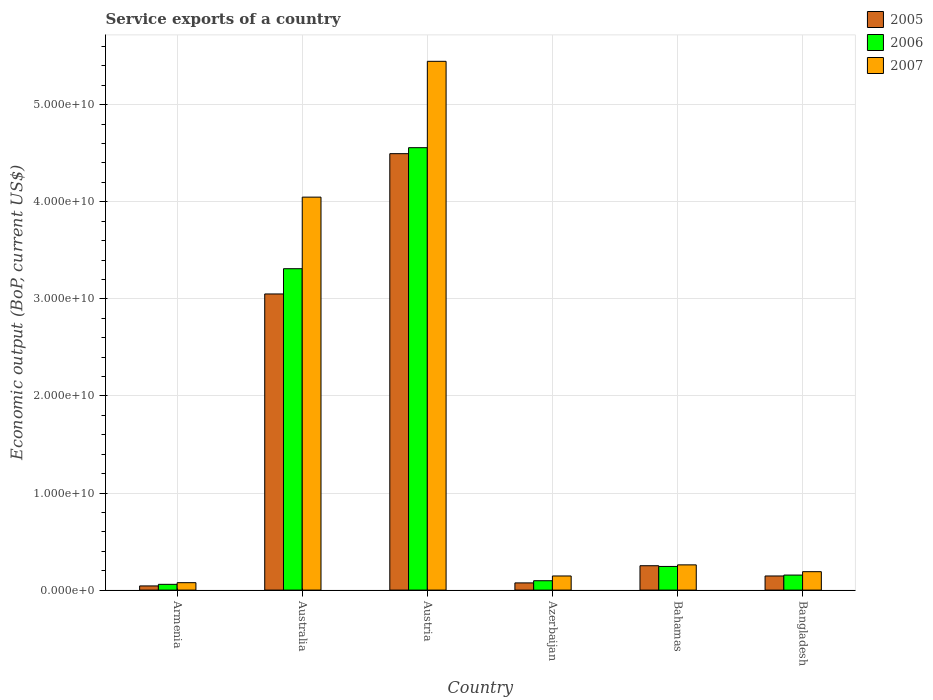How many different coloured bars are there?
Provide a short and direct response. 3. How many bars are there on the 5th tick from the left?
Offer a terse response. 3. What is the service exports in 2005 in Austria?
Your answer should be compact. 4.50e+1. Across all countries, what is the maximum service exports in 2005?
Your response must be concise. 4.50e+1. Across all countries, what is the minimum service exports in 2005?
Your answer should be compact. 4.30e+08. In which country was the service exports in 2007 maximum?
Offer a terse response. Austria. In which country was the service exports in 2006 minimum?
Your answer should be compact. Armenia. What is the total service exports in 2007 in the graph?
Ensure brevity in your answer.  1.02e+11. What is the difference between the service exports in 2007 in Armenia and that in Azerbaijan?
Your response must be concise. -6.91e+08. What is the difference between the service exports in 2007 in Bangladesh and the service exports in 2006 in Azerbaijan?
Your answer should be compact. 9.32e+08. What is the average service exports in 2005 per country?
Provide a succinct answer. 1.34e+1. What is the difference between the service exports of/in 2006 and service exports of/in 2007 in Bangladesh?
Provide a succinct answer. -3.48e+08. In how many countries, is the service exports in 2005 greater than 38000000000 US$?
Your answer should be very brief. 1. What is the ratio of the service exports in 2006 in Azerbaijan to that in Bahamas?
Provide a short and direct response. 0.4. Is the service exports in 2006 in Australia less than that in Bangladesh?
Your answer should be compact. No. What is the difference between the highest and the second highest service exports in 2006?
Provide a short and direct response. -3.07e+1. What is the difference between the highest and the lowest service exports in 2005?
Your answer should be compact. 4.45e+1. What does the 2nd bar from the left in Bangladesh represents?
Your answer should be compact. 2006. How many bars are there?
Ensure brevity in your answer.  18. Are all the bars in the graph horizontal?
Ensure brevity in your answer.  No. How many countries are there in the graph?
Offer a terse response. 6. What is the difference between two consecutive major ticks on the Y-axis?
Offer a terse response. 1.00e+1. Are the values on the major ticks of Y-axis written in scientific E-notation?
Keep it short and to the point. Yes. Does the graph contain grids?
Give a very brief answer. Yes. Where does the legend appear in the graph?
Offer a terse response. Top right. What is the title of the graph?
Ensure brevity in your answer.  Service exports of a country. Does "1988" appear as one of the legend labels in the graph?
Give a very brief answer. No. What is the label or title of the Y-axis?
Your answer should be compact. Economic output (BoP, current US$). What is the Economic output (BoP, current US$) in 2005 in Armenia?
Your answer should be compact. 4.30e+08. What is the Economic output (BoP, current US$) in 2006 in Armenia?
Offer a terse response. 5.94e+08. What is the Economic output (BoP, current US$) in 2007 in Armenia?
Provide a succinct answer. 7.64e+08. What is the Economic output (BoP, current US$) in 2005 in Australia?
Your response must be concise. 3.05e+1. What is the Economic output (BoP, current US$) of 2006 in Australia?
Keep it short and to the point. 3.31e+1. What is the Economic output (BoP, current US$) in 2007 in Australia?
Ensure brevity in your answer.  4.05e+1. What is the Economic output (BoP, current US$) of 2005 in Austria?
Your answer should be very brief. 4.50e+1. What is the Economic output (BoP, current US$) of 2006 in Austria?
Offer a very short reply. 4.56e+1. What is the Economic output (BoP, current US$) of 2007 in Austria?
Provide a short and direct response. 5.45e+1. What is the Economic output (BoP, current US$) in 2005 in Azerbaijan?
Give a very brief answer. 7.41e+08. What is the Economic output (BoP, current US$) of 2006 in Azerbaijan?
Provide a succinct answer. 9.65e+08. What is the Economic output (BoP, current US$) of 2007 in Azerbaijan?
Provide a short and direct response. 1.46e+09. What is the Economic output (BoP, current US$) of 2005 in Bahamas?
Ensure brevity in your answer.  2.51e+09. What is the Economic output (BoP, current US$) of 2006 in Bahamas?
Offer a terse response. 2.44e+09. What is the Economic output (BoP, current US$) in 2007 in Bahamas?
Your response must be concise. 2.60e+09. What is the Economic output (BoP, current US$) of 2005 in Bangladesh?
Your response must be concise. 1.45e+09. What is the Economic output (BoP, current US$) of 2006 in Bangladesh?
Your response must be concise. 1.55e+09. What is the Economic output (BoP, current US$) of 2007 in Bangladesh?
Provide a succinct answer. 1.90e+09. Across all countries, what is the maximum Economic output (BoP, current US$) of 2005?
Ensure brevity in your answer.  4.50e+1. Across all countries, what is the maximum Economic output (BoP, current US$) of 2006?
Make the answer very short. 4.56e+1. Across all countries, what is the maximum Economic output (BoP, current US$) in 2007?
Provide a succinct answer. 5.45e+1. Across all countries, what is the minimum Economic output (BoP, current US$) of 2005?
Make the answer very short. 4.30e+08. Across all countries, what is the minimum Economic output (BoP, current US$) in 2006?
Keep it short and to the point. 5.94e+08. Across all countries, what is the minimum Economic output (BoP, current US$) of 2007?
Provide a succinct answer. 7.64e+08. What is the total Economic output (BoP, current US$) of 2005 in the graph?
Offer a very short reply. 8.06e+1. What is the total Economic output (BoP, current US$) in 2006 in the graph?
Provide a short and direct response. 8.42e+1. What is the total Economic output (BoP, current US$) in 2007 in the graph?
Offer a very short reply. 1.02e+11. What is the difference between the Economic output (BoP, current US$) of 2005 in Armenia and that in Australia?
Your answer should be very brief. -3.01e+1. What is the difference between the Economic output (BoP, current US$) in 2006 in Armenia and that in Australia?
Offer a terse response. -3.25e+1. What is the difference between the Economic output (BoP, current US$) of 2007 in Armenia and that in Australia?
Your answer should be compact. -3.97e+1. What is the difference between the Economic output (BoP, current US$) in 2005 in Armenia and that in Austria?
Give a very brief answer. -4.45e+1. What is the difference between the Economic output (BoP, current US$) of 2006 in Armenia and that in Austria?
Provide a short and direct response. -4.50e+1. What is the difference between the Economic output (BoP, current US$) of 2007 in Armenia and that in Austria?
Your answer should be compact. -5.37e+1. What is the difference between the Economic output (BoP, current US$) in 2005 in Armenia and that in Azerbaijan?
Provide a short and direct response. -3.11e+08. What is the difference between the Economic output (BoP, current US$) of 2006 in Armenia and that in Azerbaijan?
Provide a succinct answer. -3.72e+08. What is the difference between the Economic output (BoP, current US$) of 2007 in Armenia and that in Azerbaijan?
Your answer should be very brief. -6.91e+08. What is the difference between the Economic output (BoP, current US$) of 2005 in Armenia and that in Bahamas?
Give a very brief answer. -2.08e+09. What is the difference between the Economic output (BoP, current US$) of 2006 in Armenia and that in Bahamas?
Offer a terse response. -1.84e+09. What is the difference between the Economic output (BoP, current US$) of 2007 in Armenia and that in Bahamas?
Offer a terse response. -1.84e+09. What is the difference between the Economic output (BoP, current US$) in 2005 in Armenia and that in Bangladesh?
Give a very brief answer. -1.02e+09. What is the difference between the Economic output (BoP, current US$) in 2006 in Armenia and that in Bangladesh?
Make the answer very short. -9.55e+08. What is the difference between the Economic output (BoP, current US$) in 2007 in Armenia and that in Bangladesh?
Keep it short and to the point. -1.13e+09. What is the difference between the Economic output (BoP, current US$) of 2005 in Australia and that in Austria?
Provide a short and direct response. -1.45e+1. What is the difference between the Economic output (BoP, current US$) of 2006 in Australia and that in Austria?
Offer a terse response. -1.25e+1. What is the difference between the Economic output (BoP, current US$) in 2007 in Australia and that in Austria?
Your answer should be compact. -1.40e+1. What is the difference between the Economic output (BoP, current US$) of 2005 in Australia and that in Azerbaijan?
Give a very brief answer. 2.98e+1. What is the difference between the Economic output (BoP, current US$) in 2006 in Australia and that in Azerbaijan?
Your response must be concise. 3.21e+1. What is the difference between the Economic output (BoP, current US$) in 2007 in Australia and that in Azerbaijan?
Provide a succinct answer. 3.90e+1. What is the difference between the Economic output (BoP, current US$) in 2005 in Australia and that in Bahamas?
Your answer should be very brief. 2.80e+1. What is the difference between the Economic output (BoP, current US$) in 2006 in Australia and that in Bahamas?
Provide a short and direct response. 3.07e+1. What is the difference between the Economic output (BoP, current US$) of 2007 in Australia and that in Bahamas?
Your response must be concise. 3.79e+1. What is the difference between the Economic output (BoP, current US$) in 2005 in Australia and that in Bangladesh?
Give a very brief answer. 2.91e+1. What is the difference between the Economic output (BoP, current US$) in 2006 in Australia and that in Bangladesh?
Offer a very short reply. 3.16e+1. What is the difference between the Economic output (BoP, current US$) in 2007 in Australia and that in Bangladesh?
Ensure brevity in your answer.  3.86e+1. What is the difference between the Economic output (BoP, current US$) of 2005 in Austria and that in Azerbaijan?
Offer a very short reply. 4.42e+1. What is the difference between the Economic output (BoP, current US$) in 2006 in Austria and that in Azerbaijan?
Keep it short and to the point. 4.46e+1. What is the difference between the Economic output (BoP, current US$) of 2007 in Austria and that in Azerbaijan?
Make the answer very short. 5.30e+1. What is the difference between the Economic output (BoP, current US$) in 2005 in Austria and that in Bahamas?
Make the answer very short. 4.24e+1. What is the difference between the Economic output (BoP, current US$) in 2006 in Austria and that in Bahamas?
Your answer should be very brief. 4.31e+1. What is the difference between the Economic output (BoP, current US$) of 2007 in Austria and that in Bahamas?
Keep it short and to the point. 5.19e+1. What is the difference between the Economic output (BoP, current US$) in 2005 in Austria and that in Bangladesh?
Offer a terse response. 4.35e+1. What is the difference between the Economic output (BoP, current US$) in 2006 in Austria and that in Bangladesh?
Provide a succinct answer. 4.40e+1. What is the difference between the Economic output (BoP, current US$) in 2007 in Austria and that in Bangladesh?
Keep it short and to the point. 5.26e+1. What is the difference between the Economic output (BoP, current US$) in 2005 in Azerbaijan and that in Bahamas?
Your answer should be very brief. -1.77e+09. What is the difference between the Economic output (BoP, current US$) of 2006 in Azerbaijan and that in Bahamas?
Provide a short and direct response. -1.47e+09. What is the difference between the Economic output (BoP, current US$) of 2007 in Azerbaijan and that in Bahamas?
Provide a succinct answer. -1.14e+09. What is the difference between the Economic output (BoP, current US$) in 2005 in Azerbaijan and that in Bangladesh?
Provide a short and direct response. -7.13e+08. What is the difference between the Economic output (BoP, current US$) in 2006 in Azerbaijan and that in Bangladesh?
Give a very brief answer. -5.84e+08. What is the difference between the Economic output (BoP, current US$) of 2007 in Azerbaijan and that in Bangladesh?
Ensure brevity in your answer.  -4.42e+08. What is the difference between the Economic output (BoP, current US$) in 2005 in Bahamas and that in Bangladesh?
Your answer should be compact. 1.06e+09. What is the difference between the Economic output (BoP, current US$) of 2006 in Bahamas and that in Bangladesh?
Offer a terse response. 8.87e+08. What is the difference between the Economic output (BoP, current US$) in 2007 in Bahamas and that in Bangladesh?
Give a very brief answer. 7.02e+08. What is the difference between the Economic output (BoP, current US$) of 2005 in Armenia and the Economic output (BoP, current US$) of 2006 in Australia?
Keep it short and to the point. -3.27e+1. What is the difference between the Economic output (BoP, current US$) of 2005 in Armenia and the Economic output (BoP, current US$) of 2007 in Australia?
Offer a terse response. -4.01e+1. What is the difference between the Economic output (BoP, current US$) of 2006 in Armenia and the Economic output (BoP, current US$) of 2007 in Australia?
Ensure brevity in your answer.  -3.99e+1. What is the difference between the Economic output (BoP, current US$) of 2005 in Armenia and the Economic output (BoP, current US$) of 2006 in Austria?
Provide a short and direct response. -4.51e+1. What is the difference between the Economic output (BoP, current US$) in 2005 in Armenia and the Economic output (BoP, current US$) in 2007 in Austria?
Provide a succinct answer. -5.40e+1. What is the difference between the Economic output (BoP, current US$) in 2006 in Armenia and the Economic output (BoP, current US$) in 2007 in Austria?
Ensure brevity in your answer.  -5.39e+1. What is the difference between the Economic output (BoP, current US$) in 2005 in Armenia and the Economic output (BoP, current US$) in 2006 in Azerbaijan?
Ensure brevity in your answer.  -5.35e+08. What is the difference between the Economic output (BoP, current US$) in 2005 in Armenia and the Economic output (BoP, current US$) in 2007 in Azerbaijan?
Your answer should be compact. -1.03e+09. What is the difference between the Economic output (BoP, current US$) of 2006 in Armenia and the Economic output (BoP, current US$) of 2007 in Azerbaijan?
Keep it short and to the point. -8.62e+08. What is the difference between the Economic output (BoP, current US$) of 2005 in Armenia and the Economic output (BoP, current US$) of 2006 in Bahamas?
Keep it short and to the point. -2.01e+09. What is the difference between the Economic output (BoP, current US$) in 2005 in Armenia and the Economic output (BoP, current US$) in 2007 in Bahamas?
Give a very brief answer. -2.17e+09. What is the difference between the Economic output (BoP, current US$) in 2006 in Armenia and the Economic output (BoP, current US$) in 2007 in Bahamas?
Offer a terse response. -2.01e+09. What is the difference between the Economic output (BoP, current US$) in 2005 in Armenia and the Economic output (BoP, current US$) in 2006 in Bangladesh?
Provide a short and direct response. -1.12e+09. What is the difference between the Economic output (BoP, current US$) of 2005 in Armenia and the Economic output (BoP, current US$) of 2007 in Bangladesh?
Keep it short and to the point. -1.47e+09. What is the difference between the Economic output (BoP, current US$) of 2006 in Armenia and the Economic output (BoP, current US$) of 2007 in Bangladesh?
Keep it short and to the point. -1.30e+09. What is the difference between the Economic output (BoP, current US$) of 2005 in Australia and the Economic output (BoP, current US$) of 2006 in Austria?
Your answer should be compact. -1.51e+1. What is the difference between the Economic output (BoP, current US$) of 2005 in Australia and the Economic output (BoP, current US$) of 2007 in Austria?
Ensure brevity in your answer.  -2.40e+1. What is the difference between the Economic output (BoP, current US$) of 2006 in Australia and the Economic output (BoP, current US$) of 2007 in Austria?
Offer a terse response. -2.14e+1. What is the difference between the Economic output (BoP, current US$) in 2005 in Australia and the Economic output (BoP, current US$) in 2006 in Azerbaijan?
Your response must be concise. 2.95e+1. What is the difference between the Economic output (BoP, current US$) of 2005 in Australia and the Economic output (BoP, current US$) of 2007 in Azerbaijan?
Offer a very short reply. 2.91e+1. What is the difference between the Economic output (BoP, current US$) in 2006 in Australia and the Economic output (BoP, current US$) in 2007 in Azerbaijan?
Provide a short and direct response. 3.17e+1. What is the difference between the Economic output (BoP, current US$) in 2005 in Australia and the Economic output (BoP, current US$) in 2006 in Bahamas?
Provide a short and direct response. 2.81e+1. What is the difference between the Economic output (BoP, current US$) of 2005 in Australia and the Economic output (BoP, current US$) of 2007 in Bahamas?
Ensure brevity in your answer.  2.79e+1. What is the difference between the Economic output (BoP, current US$) in 2006 in Australia and the Economic output (BoP, current US$) in 2007 in Bahamas?
Make the answer very short. 3.05e+1. What is the difference between the Economic output (BoP, current US$) of 2005 in Australia and the Economic output (BoP, current US$) of 2006 in Bangladesh?
Keep it short and to the point. 2.90e+1. What is the difference between the Economic output (BoP, current US$) of 2005 in Australia and the Economic output (BoP, current US$) of 2007 in Bangladesh?
Offer a very short reply. 2.86e+1. What is the difference between the Economic output (BoP, current US$) in 2006 in Australia and the Economic output (BoP, current US$) in 2007 in Bangladesh?
Provide a succinct answer. 3.12e+1. What is the difference between the Economic output (BoP, current US$) of 2005 in Austria and the Economic output (BoP, current US$) of 2006 in Azerbaijan?
Give a very brief answer. 4.40e+1. What is the difference between the Economic output (BoP, current US$) in 2005 in Austria and the Economic output (BoP, current US$) in 2007 in Azerbaijan?
Offer a very short reply. 4.35e+1. What is the difference between the Economic output (BoP, current US$) in 2006 in Austria and the Economic output (BoP, current US$) in 2007 in Azerbaijan?
Give a very brief answer. 4.41e+1. What is the difference between the Economic output (BoP, current US$) of 2005 in Austria and the Economic output (BoP, current US$) of 2006 in Bahamas?
Your answer should be compact. 4.25e+1. What is the difference between the Economic output (BoP, current US$) in 2005 in Austria and the Economic output (BoP, current US$) in 2007 in Bahamas?
Offer a very short reply. 4.24e+1. What is the difference between the Economic output (BoP, current US$) in 2006 in Austria and the Economic output (BoP, current US$) in 2007 in Bahamas?
Offer a terse response. 4.30e+1. What is the difference between the Economic output (BoP, current US$) of 2005 in Austria and the Economic output (BoP, current US$) of 2006 in Bangladesh?
Offer a very short reply. 4.34e+1. What is the difference between the Economic output (BoP, current US$) in 2005 in Austria and the Economic output (BoP, current US$) in 2007 in Bangladesh?
Your answer should be compact. 4.31e+1. What is the difference between the Economic output (BoP, current US$) in 2006 in Austria and the Economic output (BoP, current US$) in 2007 in Bangladesh?
Provide a succinct answer. 4.37e+1. What is the difference between the Economic output (BoP, current US$) in 2005 in Azerbaijan and the Economic output (BoP, current US$) in 2006 in Bahamas?
Ensure brevity in your answer.  -1.69e+09. What is the difference between the Economic output (BoP, current US$) of 2005 in Azerbaijan and the Economic output (BoP, current US$) of 2007 in Bahamas?
Make the answer very short. -1.86e+09. What is the difference between the Economic output (BoP, current US$) of 2006 in Azerbaijan and the Economic output (BoP, current US$) of 2007 in Bahamas?
Offer a very short reply. -1.63e+09. What is the difference between the Economic output (BoP, current US$) of 2005 in Azerbaijan and the Economic output (BoP, current US$) of 2006 in Bangladesh?
Keep it short and to the point. -8.08e+08. What is the difference between the Economic output (BoP, current US$) in 2005 in Azerbaijan and the Economic output (BoP, current US$) in 2007 in Bangladesh?
Ensure brevity in your answer.  -1.16e+09. What is the difference between the Economic output (BoP, current US$) of 2006 in Azerbaijan and the Economic output (BoP, current US$) of 2007 in Bangladesh?
Provide a short and direct response. -9.32e+08. What is the difference between the Economic output (BoP, current US$) in 2005 in Bahamas and the Economic output (BoP, current US$) in 2006 in Bangladesh?
Provide a short and direct response. 9.62e+08. What is the difference between the Economic output (BoP, current US$) in 2005 in Bahamas and the Economic output (BoP, current US$) in 2007 in Bangladesh?
Your answer should be compact. 6.14e+08. What is the difference between the Economic output (BoP, current US$) of 2006 in Bahamas and the Economic output (BoP, current US$) of 2007 in Bangladesh?
Your response must be concise. 5.39e+08. What is the average Economic output (BoP, current US$) of 2005 per country?
Give a very brief answer. 1.34e+1. What is the average Economic output (BoP, current US$) of 2006 per country?
Keep it short and to the point. 1.40e+1. What is the average Economic output (BoP, current US$) in 2007 per country?
Keep it short and to the point. 1.69e+1. What is the difference between the Economic output (BoP, current US$) in 2005 and Economic output (BoP, current US$) in 2006 in Armenia?
Give a very brief answer. -1.64e+08. What is the difference between the Economic output (BoP, current US$) of 2005 and Economic output (BoP, current US$) of 2007 in Armenia?
Ensure brevity in your answer.  -3.34e+08. What is the difference between the Economic output (BoP, current US$) of 2006 and Economic output (BoP, current US$) of 2007 in Armenia?
Give a very brief answer. -1.70e+08. What is the difference between the Economic output (BoP, current US$) of 2005 and Economic output (BoP, current US$) of 2006 in Australia?
Make the answer very short. -2.60e+09. What is the difference between the Economic output (BoP, current US$) in 2005 and Economic output (BoP, current US$) in 2007 in Australia?
Keep it short and to the point. -9.97e+09. What is the difference between the Economic output (BoP, current US$) of 2006 and Economic output (BoP, current US$) of 2007 in Australia?
Your answer should be very brief. -7.37e+09. What is the difference between the Economic output (BoP, current US$) in 2005 and Economic output (BoP, current US$) in 2006 in Austria?
Your response must be concise. -6.15e+08. What is the difference between the Economic output (BoP, current US$) in 2005 and Economic output (BoP, current US$) in 2007 in Austria?
Provide a succinct answer. -9.51e+09. What is the difference between the Economic output (BoP, current US$) of 2006 and Economic output (BoP, current US$) of 2007 in Austria?
Your response must be concise. -8.90e+09. What is the difference between the Economic output (BoP, current US$) of 2005 and Economic output (BoP, current US$) of 2006 in Azerbaijan?
Keep it short and to the point. -2.24e+08. What is the difference between the Economic output (BoP, current US$) of 2005 and Economic output (BoP, current US$) of 2007 in Azerbaijan?
Your response must be concise. -7.14e+08. What is the difference between the Economic output (BoP, current US$) of 2006 and Economic output (BoP, current US$) of 2007 in Azerbaijan?
Your answer should be compact. -4.90e+08. What is the difference between the Economic output (BoP, current US$) in 2005 and Economic output (BoP, current US$) in 2006 in Bahamas?
Your response must be concise. 7.48e+07. What is the difference between the Economic output (BoP, current US$) in 2005 and Economic output (BoP, current US$) in 2007 in Bahamas?
Give a very brief answer. -8.84e+07. What is the difference between the Economic output (BoP, current US$) of 2006 and Economic output (BoP, current US$) of 2007 in Bahamas?
Give a very brief answer. -1.63e+08. What is the difference between the Economic output (BoP, current US$) in 2005 and Economic output (BoP, current US$) in 2006 in Bangladesh?
Your answer should be compact. -9.44e+07. What is the difference between the Economic output (BoP, current US$) in 2005 and Economic output (BoP, current US$) in 2007 in Bangladesh?
Provide a short and direct response. -4.43e+08. What is the difference between the Economic output (BoP, current US$) in 2006 and Economic output (BoP, current US$) in 2007 in Bangladesh?
Ensure brevity in your answer.  -3.48e+08. What is the ratio of the Economic output (BoP, current US$) of 2005 in Armenia to that in Australia?
Provide a short and direct response. 0.01. What is the ratio of the Economic output (BoP, current US$) of 2006 in Armenia to that in Australia?
Offer a terse response. 0.02. What is the ratio of the Economic output (BoP, current US$) of 2007 in Armenia to that in Australia?
Your answer should be very brief. 0.02. What is the ratio of the Economic output (BoP, current US$) in 2005 in Armenia to that in Austria?
Provide a succinct answer. 0.01. What is the ratio of the Economic output (BoP, current US$) of 2006 in Armenia to that in Austria?
Offer a terse response. 0.01. What is the ratio of the Economic output (BoP, current US$) of 2007 in Armenia to that in Austria?
Provide a short and direct response. 0.01. What is the ratio of the Economic output (BoP, current US$) of 2005 in Armenia to that in Azerbaijan?
Give a very brief answer. 0.58. What is the ratio of the Economic output (BoP, current US$) in 2006 in Armenia to that in Azerbaijan?
Provide a succinct answer. 0.62. What is the ratio of the Economic output (BoP, current US$) in 2007 in Armenia to that in Azerbaijan?
Make the answer very short. 0.53. What is the ratio of the Economic output (BoP, current US$) of 2005 in Armenia to that in Bahamas?
Ensure brevity in your answer.  0.17. What is the ratio of the Economic output (BoP, current US$) in 2006 in Armenia to that in Bahamas?
Provide a short and direct response. 0.24. What is the ratio of the Economic output (BoP, current US$) in 2007 in Armenia to that in Bahamas?
Your answer should be compact. 0.29. What is the ratio of the Economic output (BoP, current US$) in 2005 in Armenia to that in Bangladesh?
Your answer should be very brief. 0.3. What is the ratio of the Economic output (BoP, current US$) in 2006 in Armenia to that in Bangladesh?
Keep it short and to the point. 0.38. What is the ratio of the Economic output (BoP, current US$) of 2007 in Armenia to that in Bangladesh?
Keep it short and to the point. 0.4. What is the ratio of the Economic output (BoP, current US$) of 2005 in Australia to that in Austria?
Offer a terse response. 0.68. What is the ratio of the Economic output (BoP, current US$) in 2006 in Australia to that in Austria?
Give a very brief answer. 0.73. What is the ratio of the Economic output (BoP, current US$) in 2007 in Australia to that in Austria?
Your answer should be very brief. 0.74. What is the ratio of the Economic output (BoP, current US$) of 2005 in Australia to that in Azerbaijan?
Your response must be concise. 41.14. What is the ratio of the Economic output (BoP, current US$) of 2006 in Australia to that in Azerbaijan?
Ensure brevity in your answer.  34.3. What is the ratio of the Economic output (BoP, current US$) of 2007 in Australia to that in Azerbaijan?
Ensure brevity in your answer.  27.81. What is the ratio of the Economic output (BoP, current US$) of 2005 in Australia to that in Bahamas?
Make the answer very short. 12.15. What is the ratio of the Economic output (BoP, current US$) of 2006 in Australia to that in Bahamas?
Keep it short and to the point. 13.59. What is the ratio of the Economic output (BoP, current US$) of 2007 in Australia to that in Bahamas?
Give a very brief answer. 15.57. What is the ratio of the Economic output (BoP, current US$) in 2005 in Australia to that in Bangladesh?
Give a very brief answer. 20.97. What is the ratio of the Economic output (BoP, current US$) in 2006 in Australia to that in Bangladesh?
Provide a succinct answer. 21.37. What is the ratio of the Economic output (BoP, current US$) of 2007 in Australia to that in Bangladesh?
Your answer should be compact. 21.34. What is the ratio of the Economic output (BoP, current US$) of 2005 in Austria to that in Azerbaijan?
Keep it short and to the point. 60.64. What is the ratio of the Economic output (BoP, current US$) of 2006 in Austria to that in Azerbaijan?
Your answer should be compact. 47.21. What is the ratio of the Economic output (BoP, current US$) in 2007 in Austria to that in Azerbaijan?
Your answer should be very brief. 37.43. What is the ratio of the Economic output (BoP, current US$) of 2005 in Austria to that in Bahamas?
Offer a terse response. 17.91. What is the ratio of the Economic output (BoP, current US$) in 2006 in Austria to that in Bahamas?
Keep it short and to the point. 18.71. What is the ratio of the Economic output (BoP, current US$) of 2007 in Austria to that in Bahamas?
Make the answer very short. 20.96. What is the ratio of the Economic output (BoP, current US$) in 2005 in Austria to that in Bangladesh?
Ensure brevity in your answer.  30.91. What is the ratio of the Economic output (BoP, current US$) in 2006 in Austria to that in Bangladesh?
Provide a short and direct response. 29.42. What is the ratio of the Economic output (BoP, current US$) of 2007 in Austria to that in Bangladesh?
Your response must be concise. 28.71. What is the ratio of the Economic output (BoP, current US$) in 2005 in Azerbaijan to that in Bahamas?
Give a very brief answer. 0.3. What is the ratio of the Economic output (BoP, current US$) in 2006 in Azerbaijan to that in Bahamas?
Provide a short and direct response. 0.4. What is the ratio of the Economic output (BoP, current US$) in 2007 in Azerbaijan to that in Bahamas?
Offer a very short reply. 0.56. What is the ratio of the Economic output (BoP, current US$) of 2005 in Azerbaijan to that in Bangladesh?
Offer a very short reply. 0.51. What is the ratio of the Economic output (BoP, current US$) in 2006 in Azerbaijan to that in Bangladesh?
Provide a short and direct response. 0.62. What is the ratio of the Economic output (BoP, current US$) of 2007 in Azerbaijan to that in Bangladesh?
Ensure brevity in your answer.  0.77. What is the ratio of the Economic output (BoP, current US$) in 2005 in Bahamas to that in Bangladesh?
Provide a succinct answer. 1.73. What is the ratio of the Economic output (BoP, current US$) in 2006 in Bahamas to that in Bangladesh?
Your answer should be compact. 1.57. What is the ratio of the Economic output (BoP, current US$) of 2007 in Bahamas to that in Bangladesh?
Offer a very short reply. 1.37. What is the difference between the highest and the second highest Economic output (BoP, current US$) of 2005?
Make the answer very short. 1.45e+1. What is the difference between the highest and the second highest Economic output (BoP, current US$) in 2006?
Make the answer very short. 1.25e+1. What is the difference between the highest and the second highest Economic output (BoP, current US$) of 2007?
Keep it short and to the point. 1.40e+1. What is the difference between the highest and the lowest Economic output (BoP, current US$) of 2005?
Your answer should be compact. 4.45e+1. What is the difference between the highest and the lowest Economic output (BoP, current US$) of 2006?
Offer a very short reply. 4.50e+1. What is the difference between the highest and the lowest Economic output (BoP, current US$) of 2007?
Ensure brevity in your answer.  5.37e+1. 